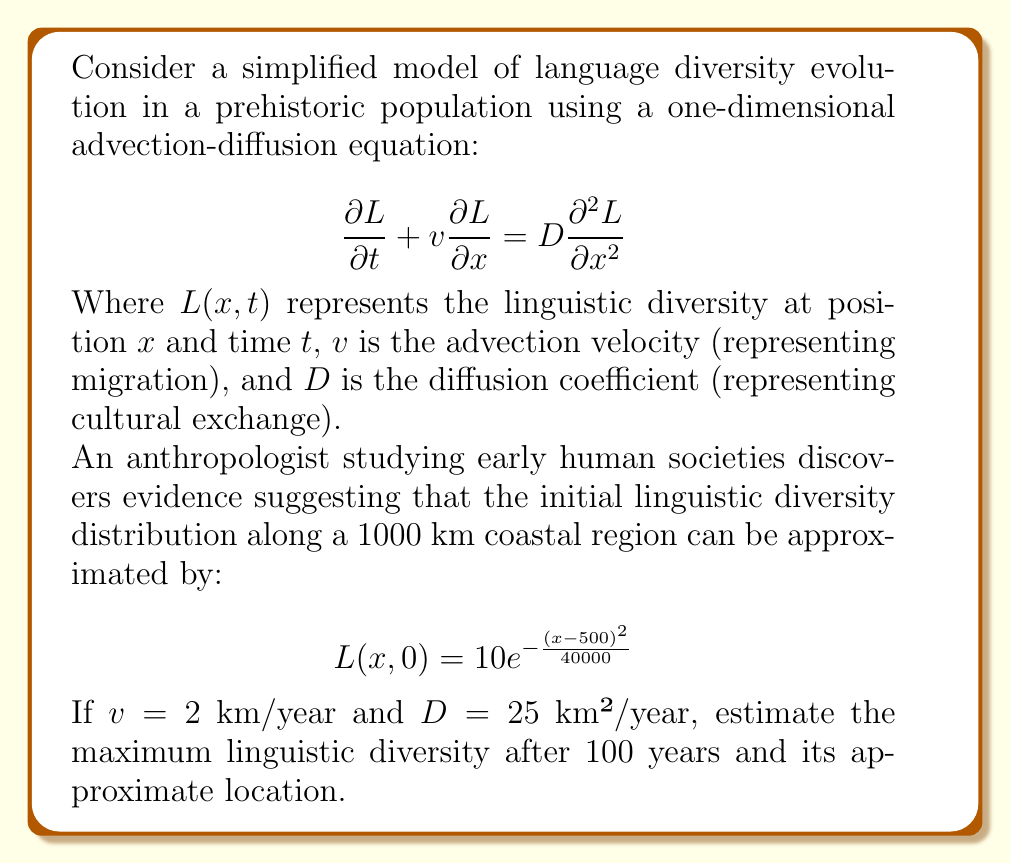Give your solution to this math problem. To solve this problem, we need to consider the evolution of the initial Gaussian distribution under the advection-diffusion equation. The solution to this equation for an initial Gaussian distribution is another Gaussian distribution that spreads out and moves over time.

1) The initial distribution is:
   $$L(x,0) = 10e^{-\frac{(x-500)^2}{40000}}$$
   This is a Gaussian with amplitude 10, centered at x = 500 km, with initial variance $\sigma_0^2 = 20000$ km².

2) For an advection-diffusion equation, the Gaussian solution at time t is:
   $$L(x,t) = \frac{A_0\sigma_0}{\sqrt{\sigma_0^2 + 2Dt}}e^{-\frac{(x-x_0-vt)^2}{2(\sigma_0^2 + 2Dt)}}$$
   Where $A_0$ is the initial amplitude, $x_0$ is the initial center, and $\sigma_0^2$ is the initial variance.

3) After 100 years:
   - The center will have moved: $500 + 2 * 100 = 700$ km
   - The variance will have increased: $20000 + 2 * 25 * 100 = 25000$ km²

4) The new amplitude will be:
   $$A(t) = \frac{A_0\sigma_0}{\sqrt{\sigma_0^2 + 2Dt}} = \frac{10 * \sqrt{20000}}{\sqrt{25000}} = 8.94$$

5) Therefore, the maximum linguistic diversity after 100 years will be approximately 8.94, located at x ≈ 700 km.
Answer: Maximum linguistic diversity after 100 years: 8.94
Approximate location: 700 km 